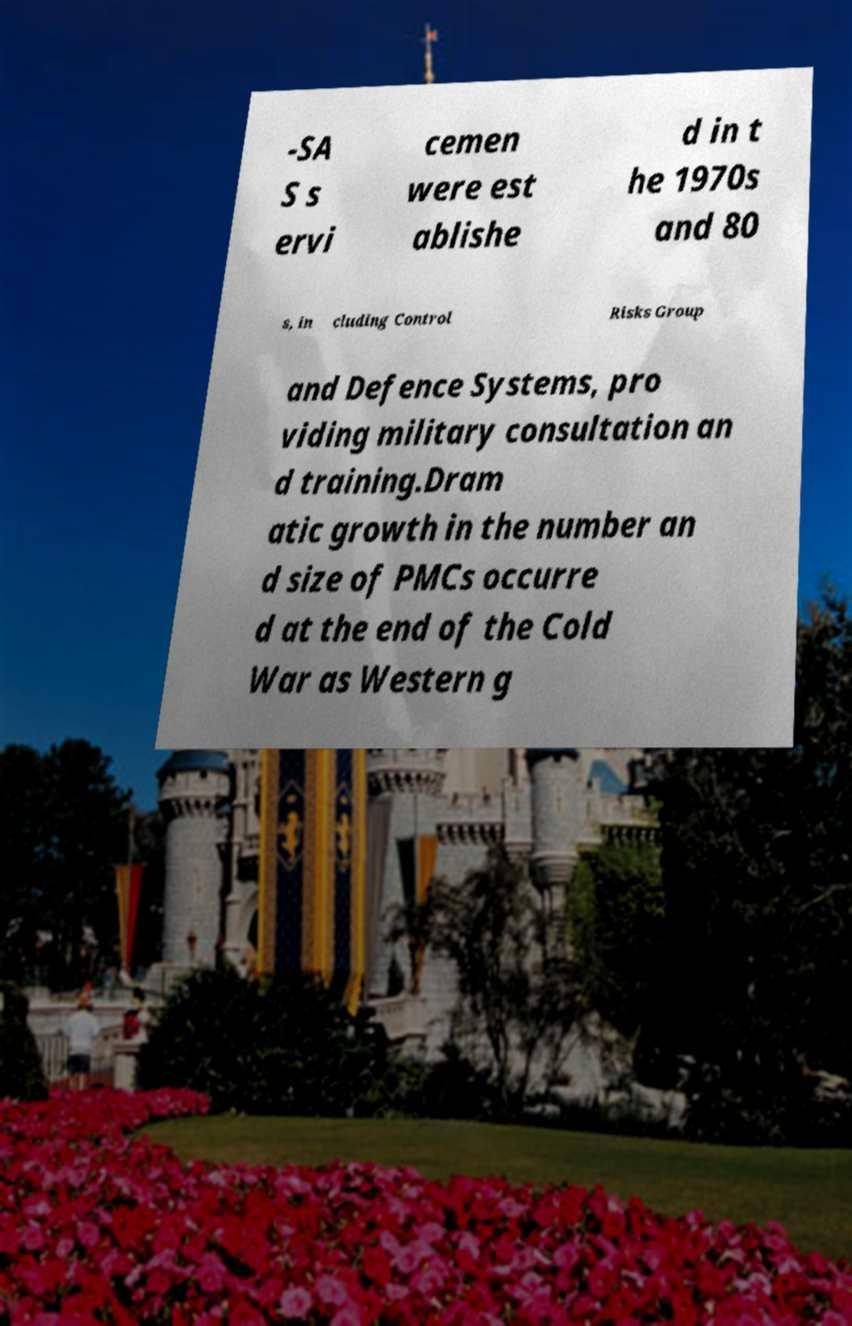Can you accurately transcribe the text from the provided image for me? -SA S s ervi cemen were est ablishe d in t he 1970s and 80 s, in cluding Control Risks Group and Defence Systems, pro viding military consultation an d training.Dram atic growth in the number an d size of PMCs occurre d at the end of the Cold War as Western g 